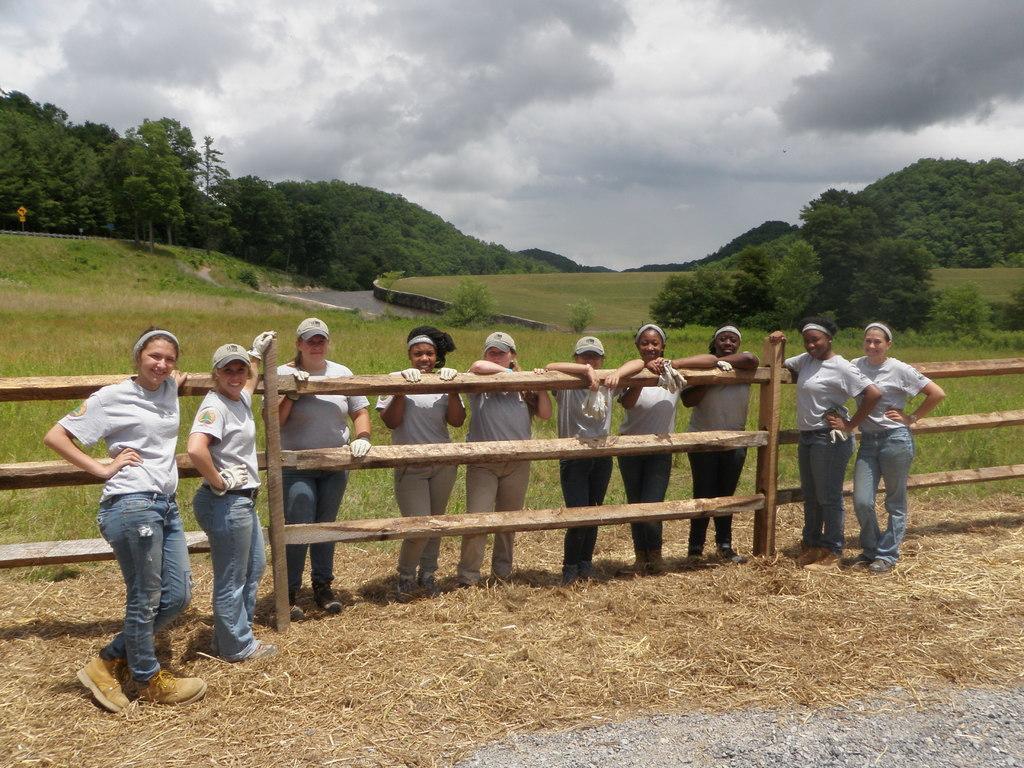How would you summarize this image in a sentence or two? In this image there are people, railings, grass, water, trees, plants, boards and cloudy sky. 